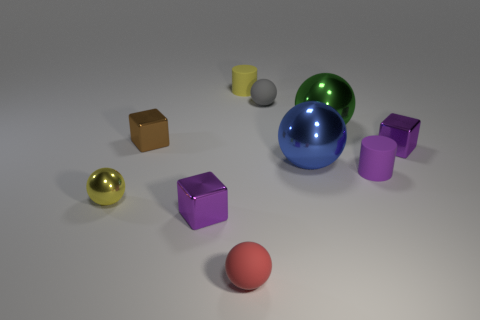Subtract all small purple blocks. How many blocks are left? 1 Subtract all green cylinders. How many purple cubes are left? 2 Subtract all gray balls. How many balls are left? 4 Subtract all purple spheres. Subtract all red cylinders. How many spheres are left? 5 Subtract 4 spheres. How many spheres are left? 1 Subtract all cubes. How many objects are left? 7 Subtract all big brown blocks. Subtract all large metallic things. How many objects are left? 8 Add 1 yellow metallic things. How many yellow metallic things are left? 2 Add 10 large yellow rubber things. How many large yellow rubber things exist? 10 Subtract 1 yellow cylinders. How many objects are left? 9 